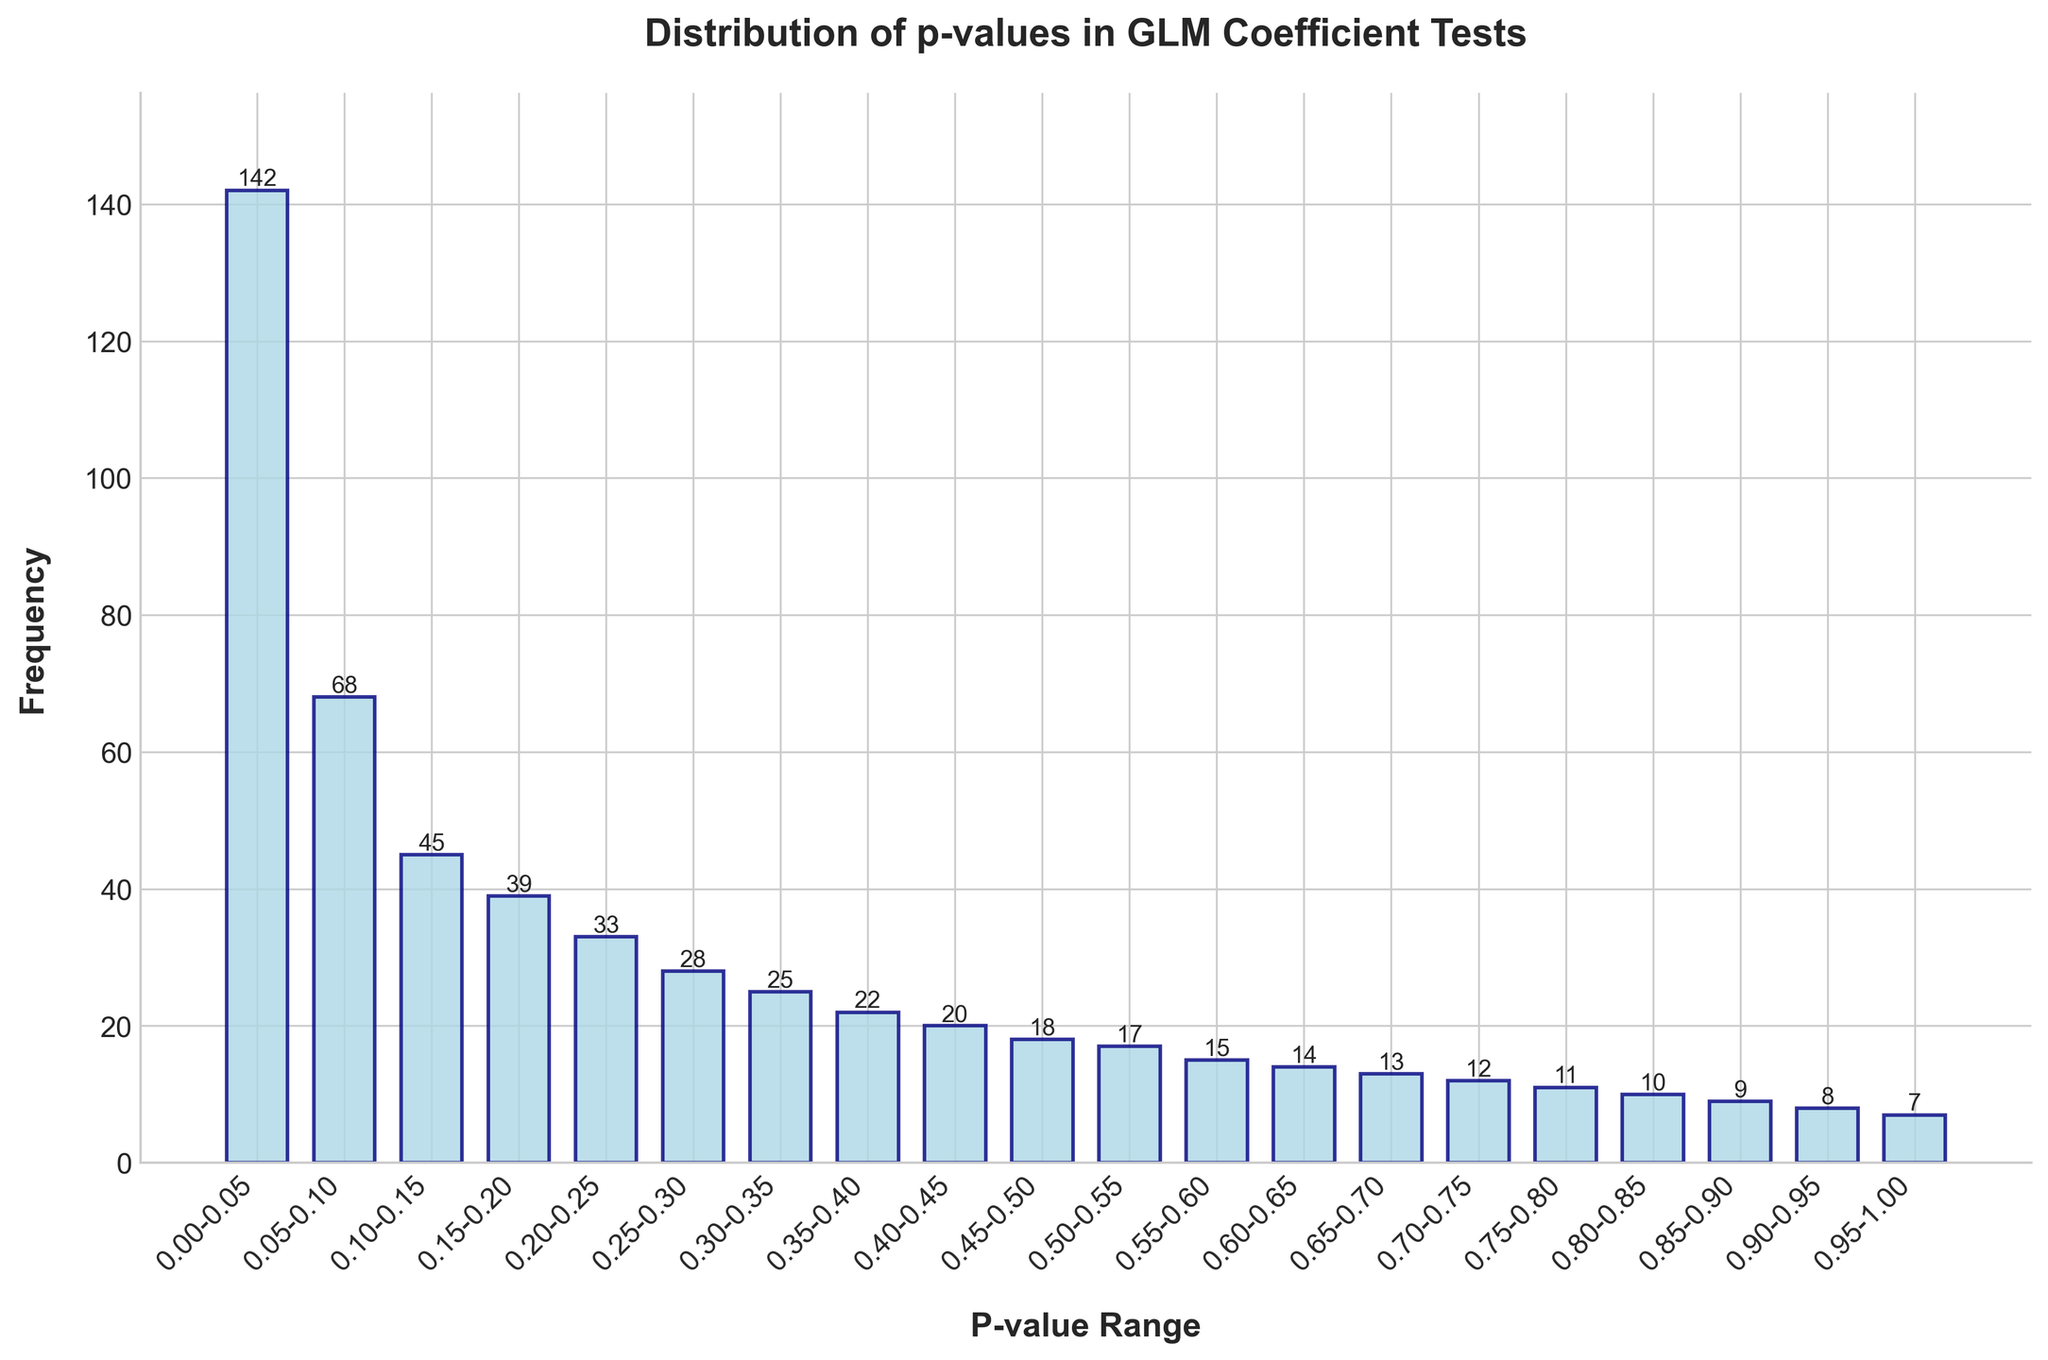Which p-value range has the highest frequency? The p-value range with the highest frequency corresponds to the tallest bar in the bar chart. By observing the bar heights, we can see that the range 0.00-0.05 has the highest frequency.
Answer: 0.00-0.05 How many p-values fall in the range 0.15-0.25? To find the number of p-values in the combined range 0.15-0.20 and 0.20-0.25, we sum up their frequencies: 39 + 33 = 72.
Answer: 72 What is the difference in frequency between the p-value ranges 0.10-0.15 and 0.55-0.60? First, find the frequencies for both ranges: 45 for 0.10-0.15 and 15 for 0.55-0.60. Then, calculate the difference: 45 - 15 = 30.
Answer: 30 Which p-value range has the lowest frequency, and what is it? The range with the lowest frequency is the one corresponding to the shortest bar. Observing the chart, the range 0.95-1.00 has the lowest frequency, which is 7.
Answer: 0.95-1.00, 7 Are there more p-values in the range 0.25-0.35 or in the range 0.75-0.85? To compare, sum the frequencies in each range: 28 (0.25-0.30) + 25 (0.30-0.35) = 53; and 11 (0.75-0.80) + 10 (0.80-0.85) = 21. The range 0.25-0.35 has a higher frequency.
Answer: 0.25-0.35 What is the average frequency of p-values in the ranges 0.05-0.15? Compute the average by summing frequencies within the range and dividing by the number of ranges: (68 + 45) / 2 = 113 / 2 = 56.5.
Answer: 56.5 Is the frequency of the p-value range 0.60-0.70 more or less than 20? Sum the frequencies for the 0.60-0.65 and 0.65-0.70 ranges: 14 + 13 = 27, which is more than 20.
Answer: More What is the combined frequency for the p-value ranges 0.90-1.00? Add the frequencies of the ranges 0.90-0.95 and 0.95-1.00: 8 + 7 = 15.
Answer: 15 Which p-value range lies just above 20 in frequency and what is it? By sorting through the frequencies, the range just above 20 is 0.35-0.40 with a frequency of 22.
Answer: 0.35-0.40, 22 How does the frequency of the range 0.00-0.05 compare to the sum of the frequencies of 0.30-0.45? Determine the frequency for 0.00-0.05 which is 142, and sum the frequencies for 0.30-0.45: 25 + 22 + 20 = 67. The frequency of 0.00-0.05 (142) is greater than 67.
Answer: Greater 